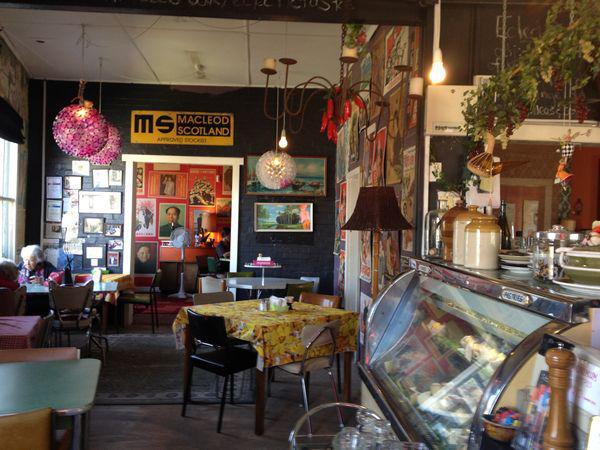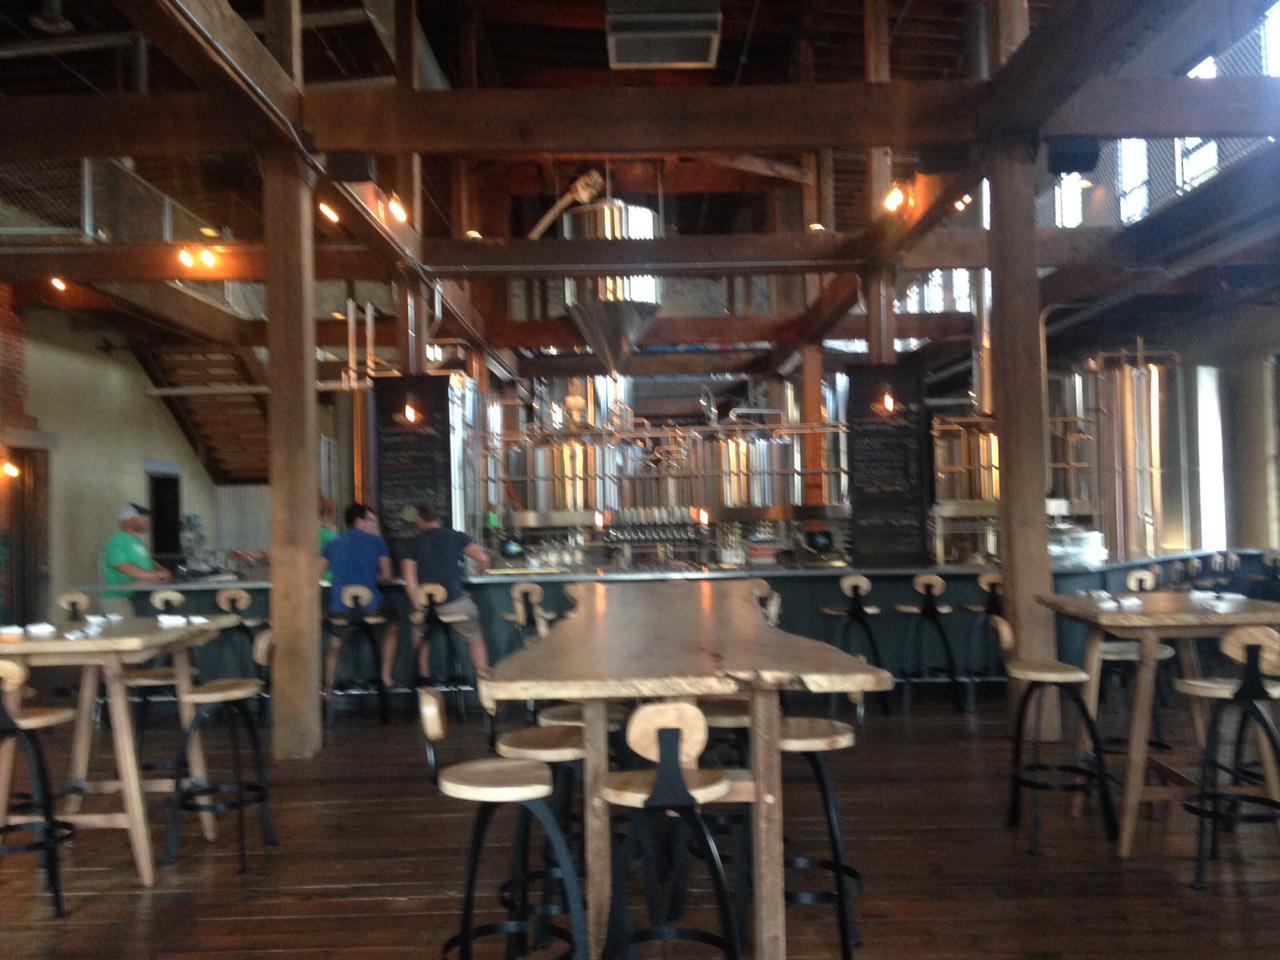The first image is the image on the left, the second image is the image on the right. Assess this claim about the two images: "People are standing at the counter of the restaurant in one of the images.". Correct or not? Answer yes or no. Yes. 